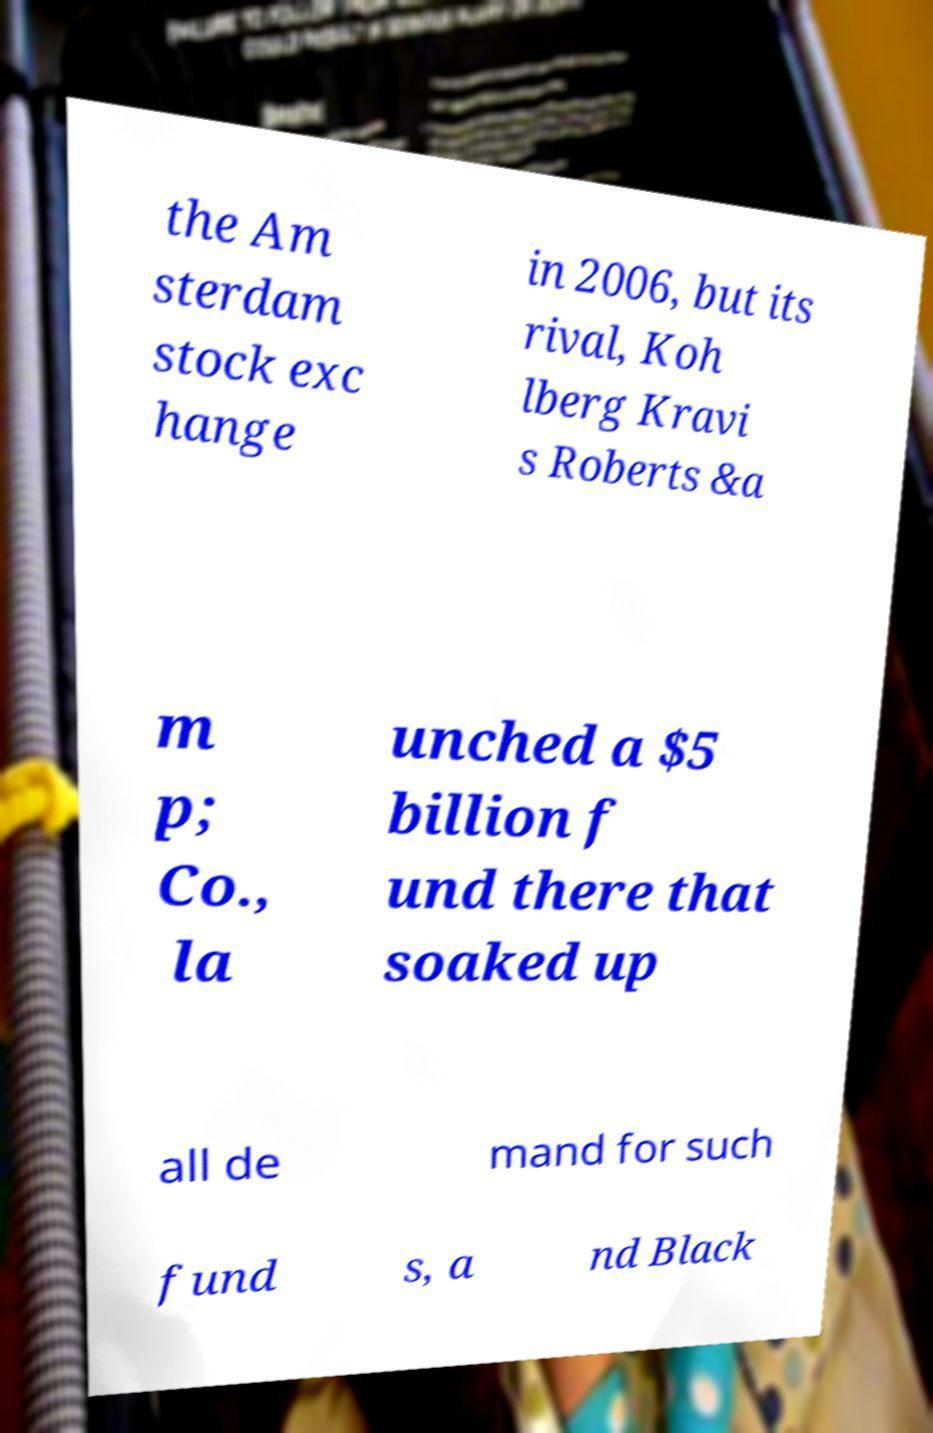What messages or text are displayed in this image? I need them in a readable, typed format. the Am sterdam stock exc hange in 2006, but its rival, Koh lberg Kravi s Roberts &a m p; Co., la unched a $5 billion f und there that soaked up all de mand for such fund s, a nd Black 